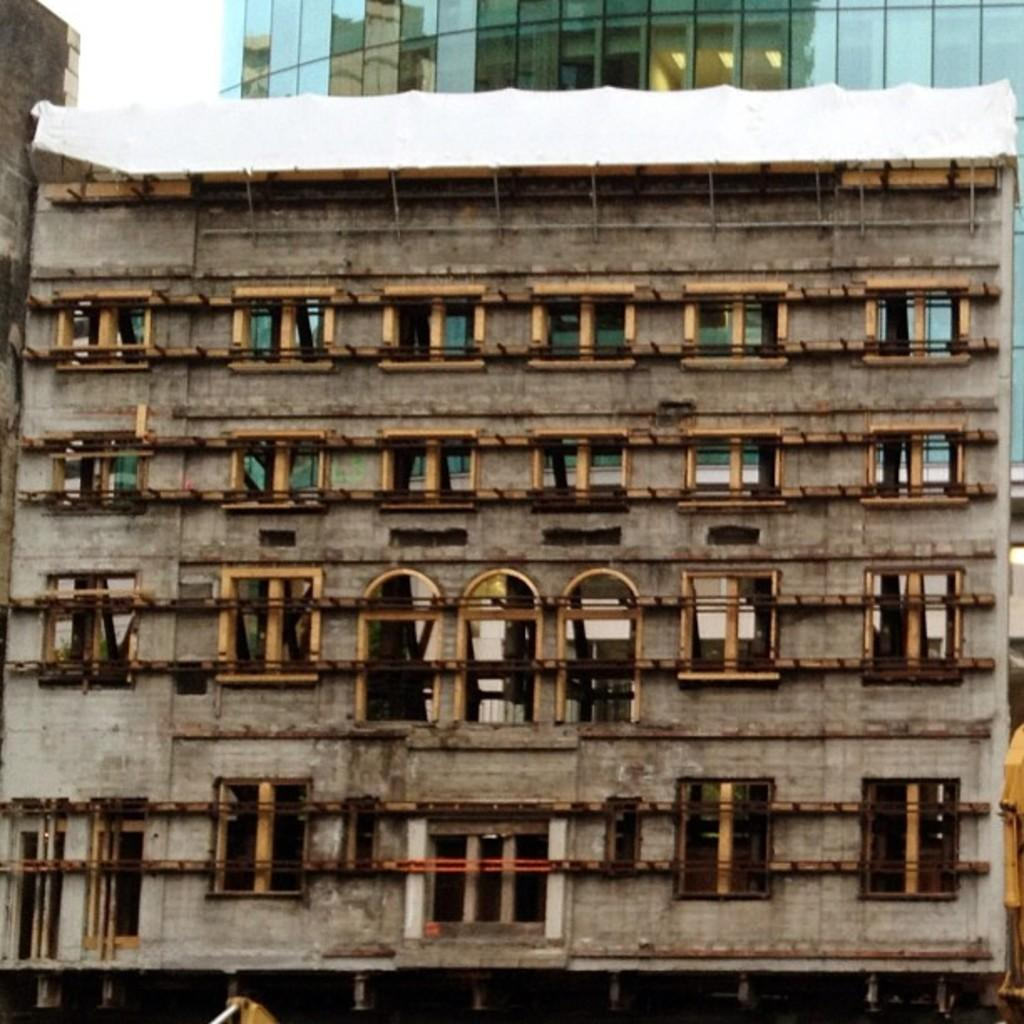What type of structures can be seen in the image? There are buildings in the image. What feature can be observed on the buildings in the image? There are glass windows in the background of the image. What else can be seen in the background of the image? There are lights visible in the background of the image. How many dimes can be seen on the ground in the image? There are no dimes present in the image. What type of slip might someone experience while walking near the buildings in the image? There is no indication of a slippery surface or any potential hazards in the image. 